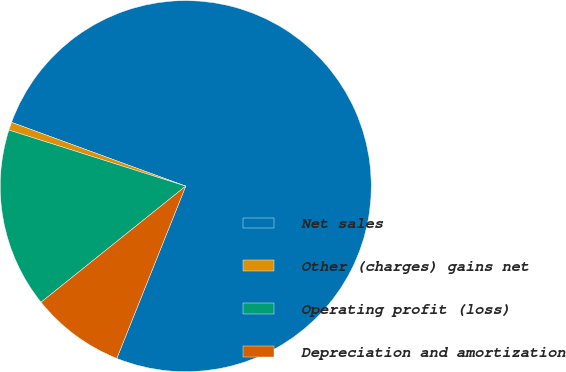Convert chart. <chart><loc_0><loc_0><loc_500><loc_500><pie_chart><fcel>Net sales<fcel>Other (charges) gains net<fcel>Operating profit (loss)<fcel>Depreciation and amortization<nl><fcel>75.47%<fcel>0.7%<fcel>15.65%<fcel>8.18%<nl></chart> 